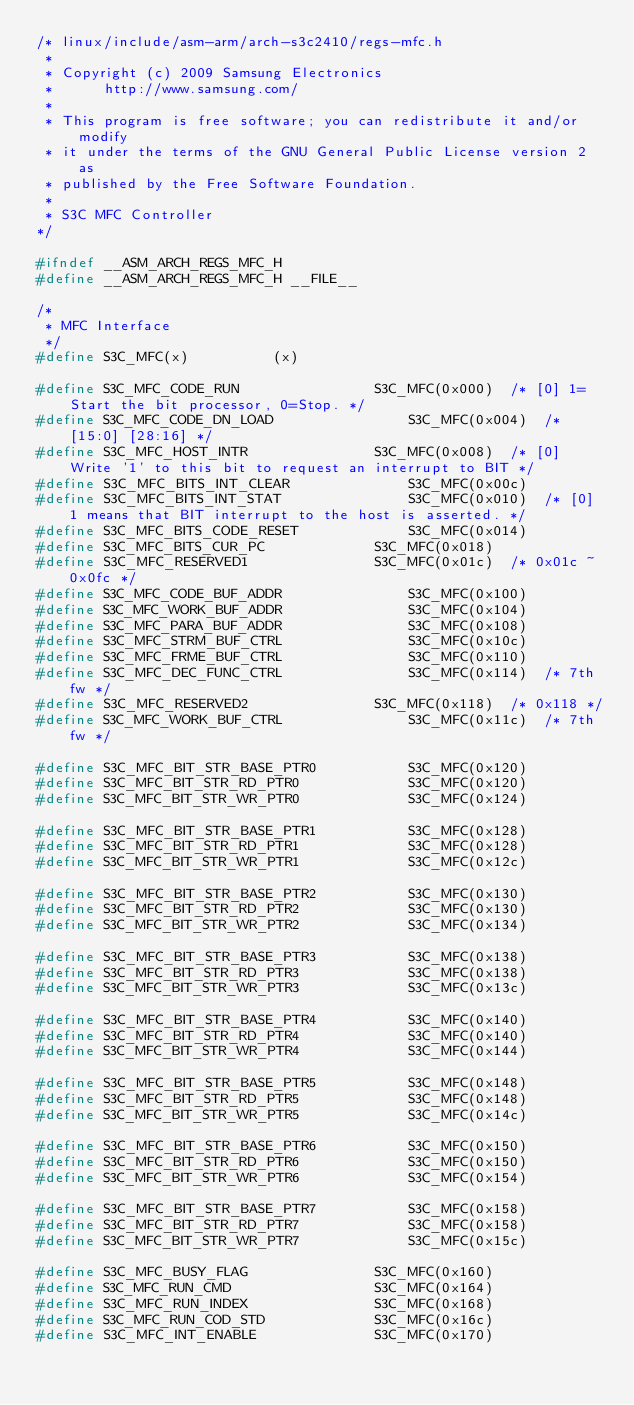<code> <loc_0><loc_0><loc_500><loc_500><_C_>/* linux/include/asm-arm/arch-s3c2410/regs-mfc.h
 *
 * Copyright (c) 2009 Samsung Electronics 
 *		http://www.samsung.com/
 *
 * This program is free software; you can redistribute it and/or modify
 * it under the terms of the GNU General Public License version 2 as
 * published by the Free Software Foundation.
 *
 * S3C MFC Controller
*/

#ifndef __ASM_ARCH_REGS_MFC_H
#define __ASM_ARCH_REGS_MFC_H __FILE__

/*
 * MFC Interface
 */
#define S3C_MFC(x)			(x)

#define S3C_MFC_CODE_RUN				S3C_MFC(0x000)	/* [0] 1=Start the bit processor, 0=Stop. */
#define S3C_MFC_CODE_DN_LOAD				S3C_MFC(0x004)	/* [15:0] [28:16] */
#define S3C_MFC_HOST_INTR				S3C_MFC(0x008)	/* [0] Write '1' to this bit to request an interrupt to BIT */
#define S3C_MFC_BITS_INT_CLEAR				S3C_MFC(0x00c)
#define S3C_MFC_BITS_INT_STAT				S3C_MFC(0x010)	/* [0] 1 means that BIT interrupt to the host is asserted. */
#define S3C_MFC_BITS_CODE_RESET				S3C_MFC(0x014)
#define S3C_MFC_BITS_CUR_PC				S3C_MFC(0x018)
#define S3C_MFC_RESERVED1				S3C_MFC(0x01c)	/* 0x01c ~ 0x0fc */
#define S3C_MFC_CODE_BUF_ADDR				S3C_MFC(0x100)
#define S3C_MFC_WORK_BUF_ADDR				S3C_MFC(0x104)
#define S3C_MFC_PARA_BUF_ADDR				S3C_MFC(0x108)
#define S3C_MFC_STRM_BUF_CTRL				S3C_MFC(0x10c)
#define S3C_MFC_FRME_BUF_CTRL				S3C_MFC(0x110)
#define S3C_MFC_DEC_FUNC_CTRL				S3C_MFC(0x114)	/* 7th fw */
#define S3C_MFC_RESERVED2				S3C_MFC(0x118)	/* 0x118 */
#define S3C_MFC_WORK_BUF_CTRL				S3C_MFC(0x11c)	/* 7th fw */

#define S3C_MFC_BIT_STR_BASE_PTR0			S3C_MFC(0x120)
#define S3C_MFC_BIT_STR_RD_PTR0				S3C_MFC(0x120)
#define S3C_MFC_BIT_STR_WR_PTR0				S3C_MFC(0x124)

#define S3C_MFC_BIT_STR_BASE_PTR1			S3C_MFC(0x128)
#define S3C_MFC_BIT_STR_RD_PTR1				S3C_MFC(0x128)
#define S3C_MFC_BIT_STR_WR_PTR1				S3C_MFC(0x12c)

#define S3C_MFC_BIT_STR_BASE_PTR2			S3C_MFC(0x130)
#define S3C_MFC_BIT_STR_RD_PTR2				S3C_MFC(0x130)
#define S3C_MFC_BIT_STR_WR_PTR2				S3C_MFC(0x134)

#define S3C_MFC_BIT_STR_BASE_PTR3			S3C_MFC(0x138)
#define S3C_MFC_BIT_STR_RD_PTR3				S3C_MFC(0x138)
#define S3C_MFC_BIT_STR_WR_PTR3				S3C_MFC(0x13c)

#define S3C_MFC_BIT_STR_BASE_PTR4			S3C_MFC(0x140)
#define S3C_MFC_BIT_STR_RD_PTR4				S3C_MFC(0x140)
#define S3C_MFC_BIT_STR_WR_PTR4				S3C_MFC(0x144)

#define S3C_MFC_BIT_STR_BASE_PTR5			S3C_MFC(0x148)
#define S3C_MFC_BIT_STR_RD_PTR5				S3C_MFC(0x148)
#define S3C_MFC_BIT_STR_WR_PTR5				S3C_MFC(0x14c)

#define S3C_MFC_BIT_STR_BASE_PTR6			S3C_MFC(0x150)
#define S3C_MFC_BIT_STR_RD_PTR6				S3C_MFC(0x150)
#define S3C_MFC_BIT_STR_WR_PTR6				S3C_MFC(0x154)

#define S3C_MFC_BIT_STR_BASE_PTR7			S3C_MFC(0x158)
#define S3C_MFC_BIT_STR_RD_PTR7				S3C_MFC(0x158)
#define S3C_MFC_BIT_STR_WR_PTR7				S3C_MFC(0x15c)

#define S3C_MFC_BUSY_FLAG				S3C_MFC(0x160)
#define S3C_MFC_RUN_CMD					S3C_MFC(0x164)
#define S3C_MFC_RUN_INDEX				S3C_MFC(0x168)
#define S3C_MFC_RUN_COD_STD				S3C_MFC(0x16c)
#define S3C_MFC_INT_ENABLE				S3C_MFC(0x170)</code> 